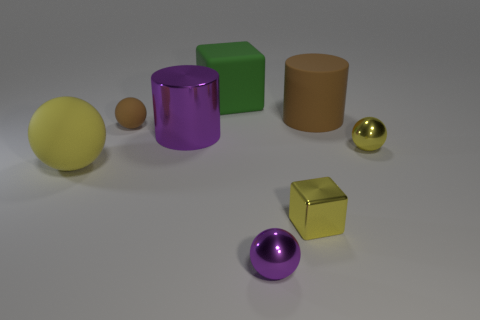Subtract all green spheres. Subtract all cyan cubes. How many spheres are left? 4 Add 2 large gray metal balls. How many objects exist? 10 Subtract all cylinders. How many objects are left? 6 Subtract 1 green cubes. How many objects are left? 7 Subtract all tiny spheres. Subtract all tiny balls. How many objects are left? 2 Add 2 large brown objects. How many large brown objects are left? 3 Add 4 big gray matte spheres. How many big gray matte spheres exist? 4 